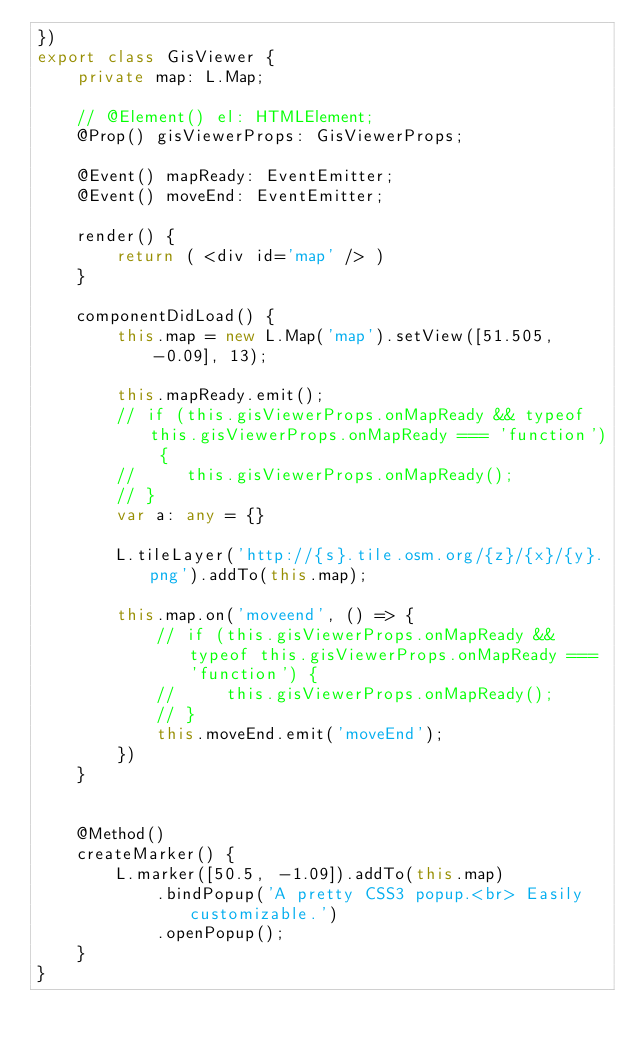<code> <loc_0><loc_0><loc_500><loc_500><_TypeScript_>})
export class GisViewer {
    private map: L.Map;

    // @Element() el: HTMLElement;
    @Prop() gisViewerProps: GisViewerProps;

    @Event() mapReady: EventEmitter;
    @Event() moveEnd: EventEmitter;

    render() {
        return ( <div id='map' /> )
    }

    componentDidLoad() {
        this.map = new L.Map('map').setView([51.505, -0.09], 13);
        
        this.mapReady.emit();
        // if (this.gisViewerProps.onMapReady && typeof this.gisViewerProps.onMapReady === 'function') {
        //     this.gisViewerProps.onMapReady();
        // }
        var a: any = {}

        L.tileLayer('http://{s}.tile.osm.org/{z}/{x}/{y}.png').addTo(this.map);

        this.map.on('moveend', () => {
            // if (this.gisViewerProps.onMapReady && typeof this.gisViewerProps.onMapReady === 'function') {
            //     this.gisViewerProps.onMapReady();
            // }
            this.moveEnd.emit('moveEnd');
        })
    }


    @Method()
    createMarker() {
        L.marker([50.5, -1.09]).addTo(this.map)
            .bindPopup('A pretty CSS3 popup.<br> Easily customizable.')
            .openPopup();
    }
}</code> 